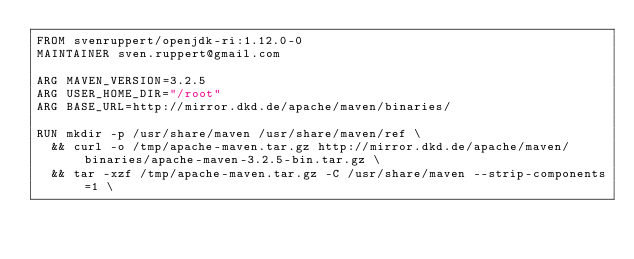Convert code to text. <code><loc_0><loc_0><loc_500><loc_500><_Dockerfile_>FROM svenruppert/openjdk-ri:1.12.0-0
MAINTAINER sven.ruppert@gmail.com

ARG MAVEN_VERSION=3.2.5
ARG USER_HOME_DIR="/root"
ARG BASE_URL=http://mirror.dkd.de/apache/maven/binaries/

RUN mkdir -p /usr/share/maven /usr/share/maven/ref \
  && curl -o /tmp/apache-maven.tar.gz http://mirror.dkd.de/apache/maven/binaries/apache-maven-3.2.5-bin.tar.gz \
  && tar -xzf /tmp/apache-maven.tar.gz -C /usr/share/maven --strip-components=1 \</code> 